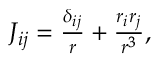<formula> <loc_0><loc_0><loc_500><loc_500>\begin{array} { r } { J _ { i j } = \frac { \delta _ { i j } } { r } + \frac { r _ { i } r _ { j } } { r ^ { 3 } } , } \end{array}</formula> 